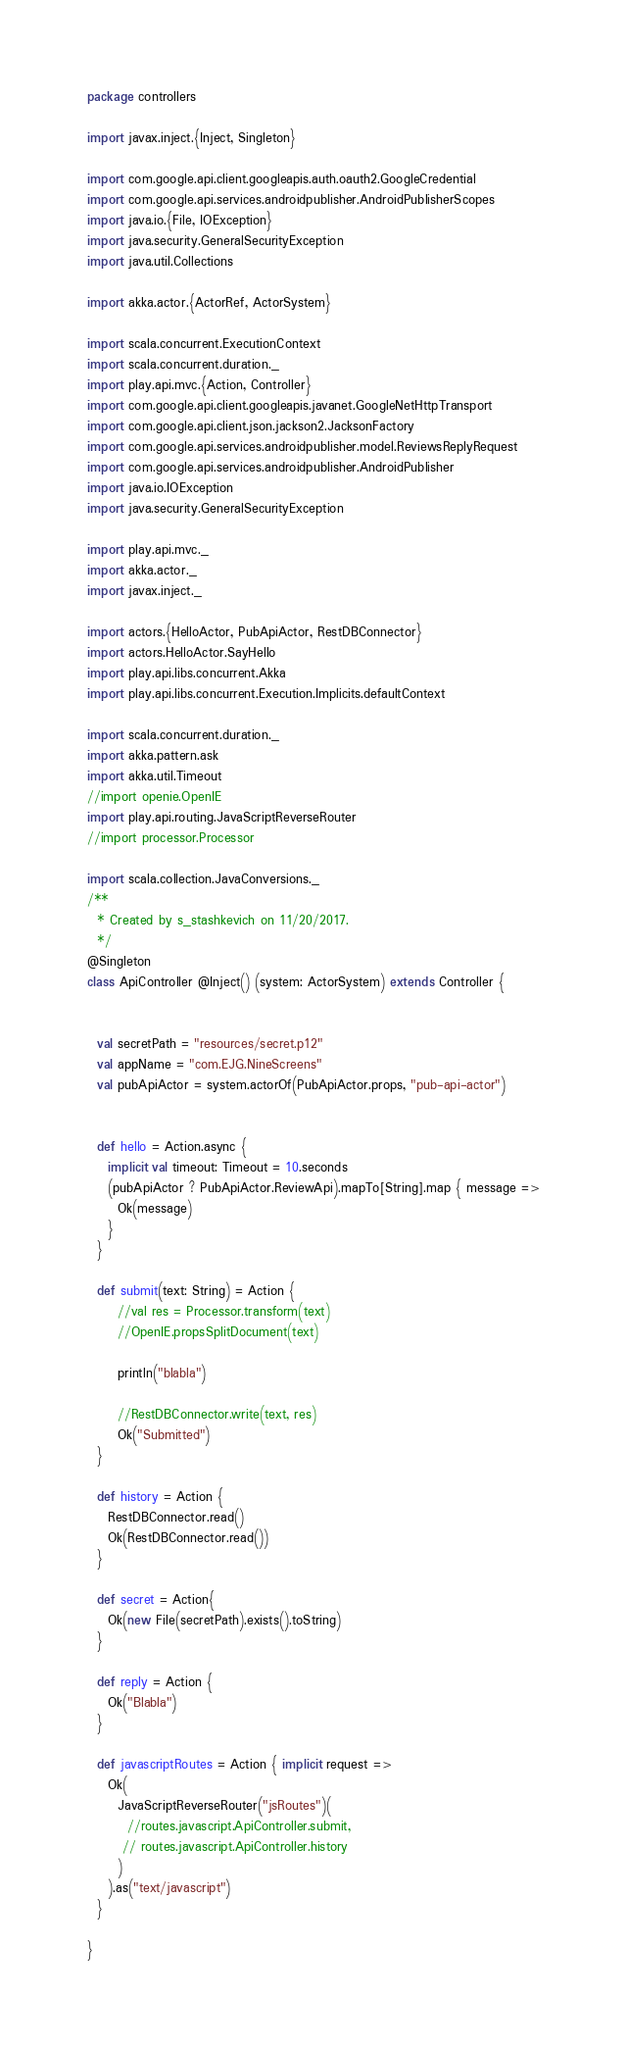Convert code to text. <code><loc_0><loc_0><loc_500><loc_500><_Scala_>package controllers

import javax.inject.{Inject, Singleton}

import com.google.api.client.googleapis.auth.oauth2.GoogleCredential
import com.google.api.services.androidpublisher.AndroidPublisherScopes
import java.io.{File, IOException}
import java.security.GeneralSecurityException
import java.util.Collections

import akka.actor.{ActorRef, ActorSystem}

import scala.concurrent.ExecutionContext
import scala.concurrent.duration._
import play.api.mvc.{Action, Controller}
import com.google.api.client.googleapis.javanet.GoogleNetHttpTransport
import com.google.api.client.json.jackson2.JacksonFactory
import com.google.api.services.androidpublisher.model.ReviewsReplyRequest
import com.google.api.services.androidpublisher.AndroidPublisher
import java.io.IOException
import java.security.GeneralSecurityException

import play.api.mvc._
import akka.actor._
import javax.inject._

import actors.{HelloActor, PubApiActor, RestDBConnector}
import actors.HelloActor.SayHello
import play.api.libs.concurrent.Akka
import play.api.libs.concurrent.Execution.Implicits.defaultContext

import scala.concurrent.duration._
import akka.pattern.ask
import akka.util.Timeout
//import openie.OpenIE
import play.api.routing.JavaScriptReverseRouter
//import processor.Processor

import scala.collection.JavaConversions._
/**
  * Created by s_stashkevich on 11/20/2017.
  */
@Singleton
class ApiController @Inject() (system: ActorSystem) extends Controller {


  val secretPath = "resources/secret.p12"
  val appName = "com.EJG.NineScreens"
  val pubApiActor = system.actorOf(PubApiActor.props, "pub-api-actor")


  def hello = Action.async {
    implicit val timeout: Timeout = 10.seconds
    (pubApiActor ? PubApiActor.ReviewApi).mapTo[String].map { message =>
      Ok(message)
    }
  }

  def submit(text: String) = Action {
      //val res = Processor.transform(text)
      //OpenIE.propsSplitDocument(text)

      println("blabla")

      //RestDBConnector.write(text, res)
      Ok("Submitted")
  }

  def history = Action {
    RestDBConnector.read()
    Ok(RestDBConnector.read())
  }

  def secret = Action{
    Ok(new File(secretPath).exists().toString)
  }

  def reply = Action {
    Ok("Blabla")
  }

  def javascriptRoutes = Action { implicit request =>
    Ok(
      JavaScriptReverseRouter("jsRoutes")(
        //routes.javascript.ApiController.submit,
       // routes.javascript.ApiController.history
      )
    ).as("text/javascript")
  }

}
</code> 